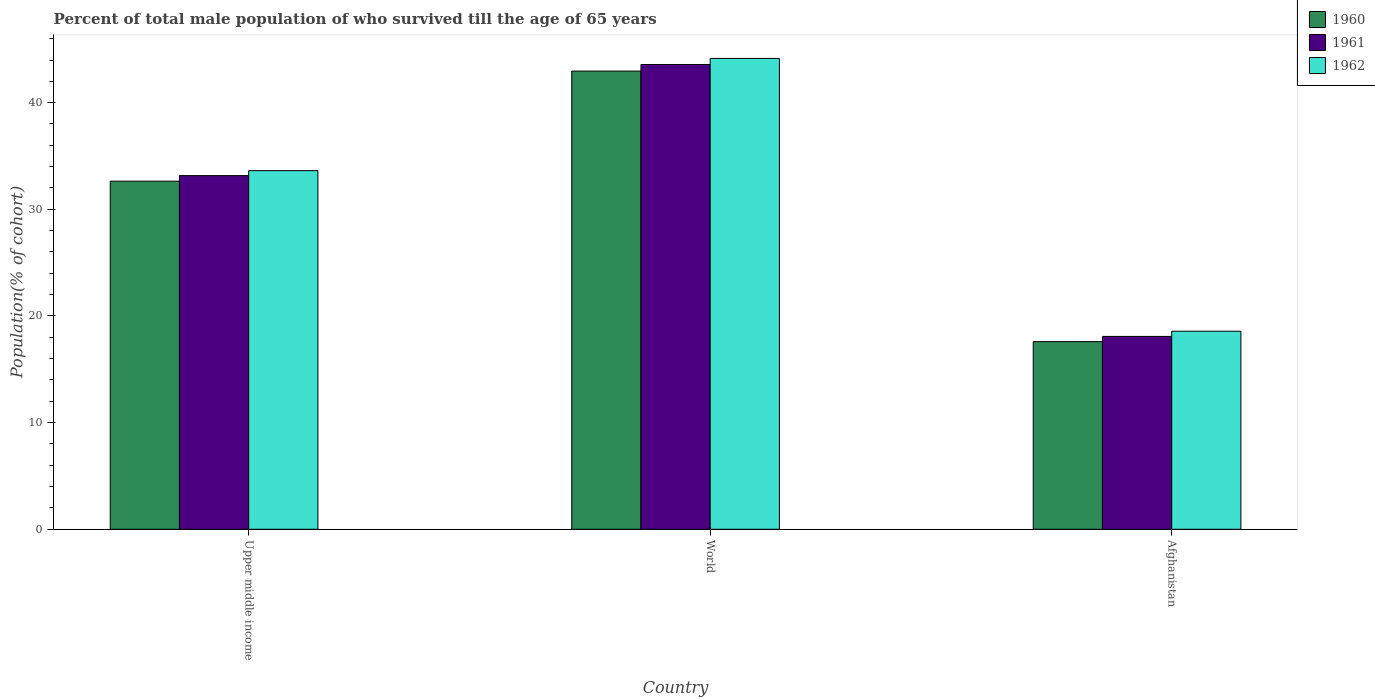How many different coloured bars are there?
Give a very brief answer. 3. How many groups of bars are there?
Your answer should be compact. 3. Are the number of bars on each tick of the X-axis equal?
Provide a short and direct response. Yes. How many bars are there on the 1st tick from the left?
Your answer should be very brief. 3. How many bars are there on the 1st tick from the right?
Offer a terse response. 3. What is the label of the 1st group of bars from the left?
Your response must be concise. Upper middle income. What is the percentage of total male population who survived till the age of 65 years in 1961 in Upper middle income?
Provide a short and direct response. 33.16. Across all countries, what is the maximum percentage of total male population who survived till the age of 65 years in 1960?
Keep it short and to the point. 42.96. Across all countries, what is the minimum percentage of total male population who survived till the age of 65 years in 1960?
Your answer should be compact. 17.59. In which country was the percentage of total male population who survived till the age of 65 years in 1960 minimum?
Offer a terse response. Afghanistan. What is the total percentage of total male population who survived till the age of 65 years in 1962 in the graph?
Offer a terse response. 96.34. What is the difference between the percentage of total male population who survived till the age of 65 years in 1962 in Upper middle income and that in World?
Ensure brevity in your answer.  -10.52. What is the difference between the percentage of total male population who survived till the age of 65 years in 1962 in World and the percentage of total male population who survived till the age of 65 years in 1961 in Afghanistan?
Keep it short and to the point. 26.07. What is the average percentage of total male population who survived till the age of 65 years in 1960 per country?
Keep it short and to the point. 31.07. What is the difference between the percentage of total male population who survived till the age of 65 years of/in 1962 and percentage of total male population who survived till the age of 65 years of/in 1960 in Upper middle income?
Keep it short and to the point. 0.99. What is the ratio of the percentage of total male population who survived till the age of 65 years in 1962 in Upper middle income to that in World?
Keep it short and to the point. 0.76. Is the percentage of total male population who survived till the age of 65 years in 1961 in Upper middle income less than that in World?
Make the answer very short. Yes. What is the difference between the highest and the second highest percentage of total male population who survived till the age of 65 years in 1960?
Your answer should be compact. 15.05. What is the difference between the highest and the lowest percentage of total male population who survived till the age of 65 years in 1962?
Ensure brevity in your answer.  25.58. Is the sum of the percentage of total male population who survived till the age of 65 years in 1960 in Afghanistan and Upper middle income greater than the maximum percentage of total male population who survived till the age of 65 years in 1961 across all countries?
Keep it short and to the point. Yes. What does the 2nd bar from the left in World represents?
Give a very brief answer. 1961. What does the 1st bar from the right in Afghanistan represents?
Provide a short and direct response. 1962. Is it the case that in every country, the sum of the percentage of total male population who survived till the age of 65 years in 1961 and percentage of total male population who survived till the age of 65 years in 1960 is greater than the percentage of total male population who survived till the age of 65 years in 1962?
Provide a short and direct response. Yes. How many bars are there?
Give a very brief answer. 9. Are the values on the major ticks of Y-axis written in scientific E-notation?
Ensure brevity in your answer.  No. How many legend labels are there?
Provide a succinct answer. 3. How are the legend labels stacked?
Your response must be concise. Vertical. What is the title of the graph?
Give a very brief answer. Percent of total male population of who survived till the age of 65 years. What is the label or title of the X-axis?
Give a very brief answer. Country. What is the label or title of the Y-axis?
Provide a succinct answer. Population(% of cohort). What is the Population(% of cohort) of 1960 in Upper middle income?
Keep it short and to the point. 32.64. What is the Population(% of cohort) in 1961 in Upper middle income?
Give a very brief answer. 33.16. What is the Population(% of cohort) of 1962 in Upper middle income?
Offer a terse response. 33.63. What is the Population(% of cohort) of 1960 in World?
Your answer should be compact. 42.96. What is the Population(% of cohort) in 1961 in World?
Provide a succinct answer. 43.58. What is the Population(% of cohort) of 1962 in World?
Offer a terse response. 44.15. What is the Population(% of cohort) of 1960 in Afghanistan?
Your answer should be very brief. 17.59. What is the Population(% of cohort) in 1961 in Afghanistan?
Your response must be concise. 18.08. What is the Population(% of cohort) of 1962 in Afghanistan?
Provide a short and direct response. 18.57. Across all countries, what is the maximum Population(% of cohort) in 1960?
Your answer should be very brief. 42.96. Across all countries, what is the maximum Population(% of cohort) in 1961?
Provide a succinct answer. 43.58. Across all countries, what is the maximum Population(% of cohort) of 1962?
Provide a succinct answer. 44.15. Across all countries, what is the minimum Population(% of cohort) in 1960?
Make the answer very short. 17.59. Across all countries, what is the minimum Population(% of cohort) of 1961?
Your answer should be compact. 18.08. Across all countries, what is the minimum Population(% of cohort) of 1962?
Offer a terse response. 18.57. What is the total Population(% of cohort) in 1960 in the graph?
Ensure brevity in your answer.  93.2. What is the total Population(% of cohort) of 1961 in the graph?
Keep it short and to the point. 94.82. What is the total Population(% of cohort) of 1962 in the graph?
Provide a short and direct response. 96.34. What is the difference between the Population(% of cohort) of 1960 in Upper middle income and that in World?
Provide a short and direct response. -10.32. What is the difference between the Population(% of cohort) in 1961 in Upper middle income and that in World?
Ensure brevity in your answer.  -10.42. What is the difference between the Population(% of cohort) in 1962 in Upper middle income and that in World?
Make the answer very short. -10.52. What is the difference between the Population(% of cohort) of 1960 in Upper middle income and that in Afghanistan?
Offer a terse response. 15.05. What is the difference between the Population(% of cohort) in 1961 in Upper middle income and that in Afghanistan?
Provide a succinct answer. 15.08. What is the difference between the Population(% of cohort) in 1962 in Upper middle income and that in Afghanistan?
Provide a short and direct response. 15.05. What is the difference between the Population(% of cohort) of 1960 in World and that in Afghanistan?
Ensure brevity in your answer.  25.37. What is the difference between the Population(% of cohort) of 1961 in World and that in Afghanistan?
Give a very brief answer. 25.5. What is the difference between the Population(% of cohort) in 1962 in World and that in Afghanistan?
Give a very brief answer. 25.58. What is the difference between the Population(% of cohort) in 1960 in Upper middle income and the Population(% of cohort) in 1961 in World?
Keep it short and to the point. -10.94. What is the difference between the Population(% of cohort) of 1960 in Upper middle income and the Population(% of cohort) of 1962 in World?
Keep it short and to the point. -11.51. What is the difference between the Population(% of cohort) in 1961 in Upper middle income and the Population(% of cohort) in 1962 in World?
Provide a succinct answer. -10.99. What is the difference between the Population(% of cohort) of 1960 in Upper middle income and the Population(% of cohort) of 1961 in Afghanistan?
Your response must be concise. 14.56. What is the difference between the Population(% of cohort) of 1960 in Upper middle income and the Population(% of cohort) of 1962 in Afghanistan?
Ensure brevity in your answer.  14.07. What is the difference between the Population(% of cohort) of 1961 in Upper middle income and the Population(% of cohort) of 1962 in Afghanistan?
Provide a succinct answer. 14.59. What is the difference between the Population(% of cohort) of 1960 in World and the Population(% of cohort) of 1961 in Afghanistan?
Your response must be concise. 24.88. What is the difference between the Population(% of cohort) in 1960 in World and the Population(% of cohort) in 1962 in Afghanistan?
Provide a succinct answer. 24.39. What is the difference between the Population(% of cohort) of 1961 in World and the Population(% of cohort) of 1962 in Afghanistan?
Ensure brevity in your answer.  25.01. What is the average Population(% of cohort) of 1960 per country?
Your response must be concise. 31.07. What is the average Population(% of cohort) of 1961 per country?
Offer a very short reply. 31.61. What is the average Population(% of cohort) of 1962 per country?
Provide a short and direct response. 32.11. What is the difference between the Population(% of cohort) in 1960 and Population(% of cohort) in 1961 in Upper middle income?
Ensure brevity in your answer.  -0.52. What is the difference between the Population(% of cohort) in 1960 and Population(% of cohort) in 1962 in Upper middle income?
Provide a succinct answer. -0.99. What is the difference between the Population(% of cohort) in 1961 and Population(% of cohort) in 1962 in Upper middle income?
Provide a succinct answer. -0.46. What is the difference between the Population(% of cohort) of 1960 and Population(% of cohort) of 1961 in World?
Make the answer very short. -0.62. What is the difference between the Population(% of cohort) of 1960 and Population(% of cohort) of 1962 in World?
Offer a very short reply. -1.19. What is the difference between the Population(% of cohort) of 1961 and Population(% of cohort) of 1962 in World?
Your response must be concise. -0.57. What is the difference between the Population(% of cohort) of 1960 and Population(% of cohort) of 1961 in Afghanistan?
Give a very brief answer. -0.49. What is the difference between the Population(% of cohort) in 1960 and Population(% of cohort) in 1962 in Afghanistan?
Make the answer very short. -0.98. What is the difference between the Population(% of cohort) of 1961 and Population(% of cohort) of 1962 in Afghanistan?
Your answer should be very brief. -0.49. What is the ratio of the Population(% of cohort) in 1960 in Upper middle income to that in World?
Provide a short and direct response. 0.76. What is the ratio of the Population(% of cohort) of 1961 in Upper middle income to that in World?
Your answer should be compact. 0.76. What is the ratio of the Population(% of cohort) of 1962 in Upper middle income to that in World?
Provide a short and direct response. 0.76. What is the ratio of the Population(% of cohort) of 1960 in Upper middle income to that in Afghanistan?
Provide a short and direct response. 1.86. What is the ratio of the Population(% of cohort) of 1961 in Upper middle income to that in Afghanistan?
Offer a very short reply. 1.83. What is the ratio of the Population(% of cohort) of 1962 in Upper middle income to that in Afghanistan?
Provide a short and direct response. 1.81. What is the ratio of the Population(% of cohort) in 1960 in World to that in Afghanistan?
Provide a short and direct response. 2.44. What is the ratio of the Population(% of cohort) of 1961 in World to that in Afghanistan?
Your response must be concise. 2.41. What is the ratio of the Population(% of cohort) of 1962 in World to that in Afghanistan?
Make the answer very short. 2.38. What is the difference between the highest and the second highest Population(% of cohort) of 1960?
Make the answer very short. 10.32. What is the difference between the highest and the second highest Population(% of cohort) in 1961?
Offer a terse response. 10.42. What is the difference between the highest and the second highest Population(% of cohort) in 1962?
Provide a succinct answer. 10.52. What is the difference between the highest and the lowest Population(% of cohort) of 1960?
Offer a terse response. 25.37. What is the difference between the highest and the lowest Population(% of cohort) in 1961?
Provide a short and direct response. 25.5. What is the difference between the highest and the lowest Population(% of cohort) of 1962?
Your response must be concise. 25.58. 